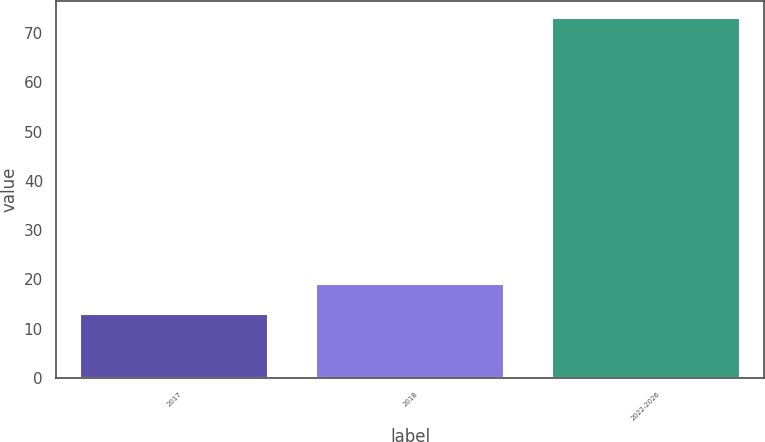Convert chart to OTSL. <chart><loc_0><loc_0><loc_500><loc_500><bar_chart><fcel>2017<fcel>2018<fcel>2022-2026<nl><fcel>13<fcel>19<fcel>73<nl></chart> 